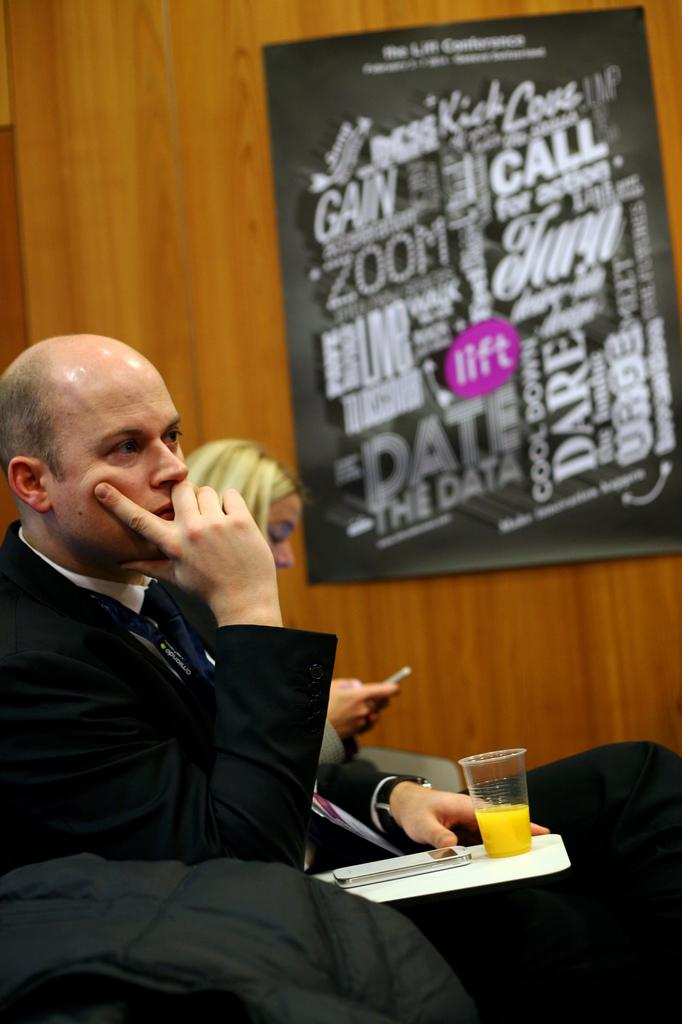<image>
Offer a succinct explanation of the picture presented. A man sitting with a cup of orange juice is in front of a poster with words such as GAIN an CALL. 